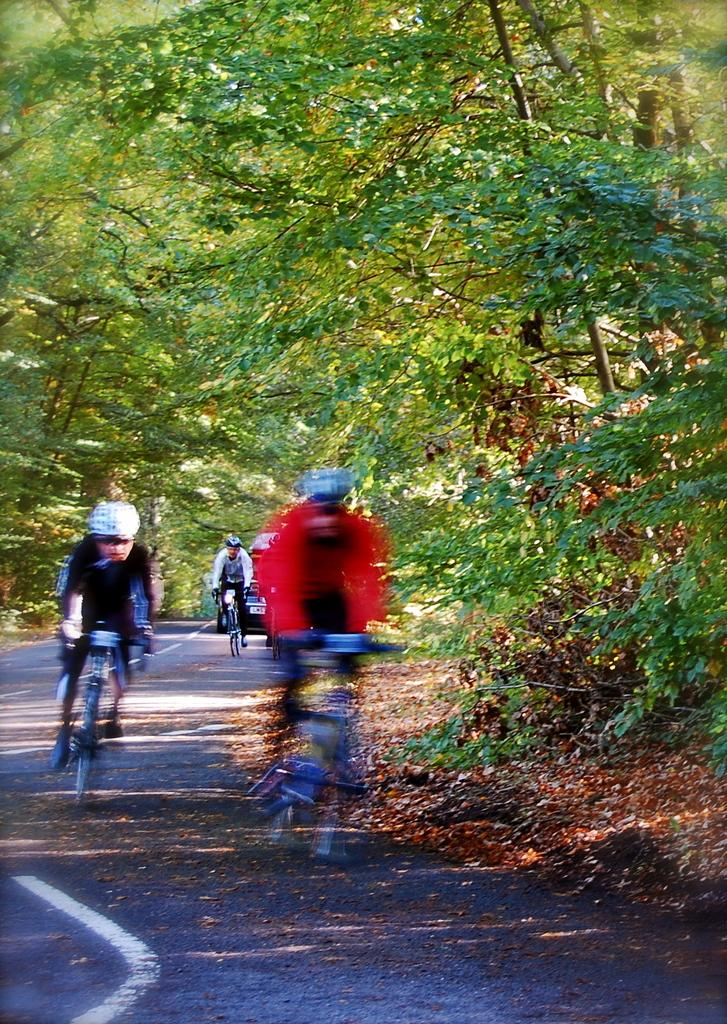What is the main feature of the image? There is a road in the image. What is the color of the road? The road is black in color. What are the people in the image doing? There are people riding bicycles on the road. What can be seen in the background of the image? There are green color plants and trees in the background. What is the rate at which the spiders are crawling on the road in the image? There are no spiders present in the image, so it is not possible to determine their crawling rate. How many clovers can be seen growing on the side of the road in the image? There is no mention of clovers in the image, so it is not possible to determine their presence or quantity. 